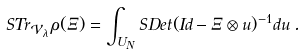Convert formula to latex. <formula><loc_0><loc_0><loc_500><loc_500>S T r _ { \mathcal { V } _ { \lambda } } \, \rho ( \Xi ) = \int _ { U _ { N } } S D e t ( I d - \Xi \otimes u ) ^ { - 1 } d u \, .</formula> 